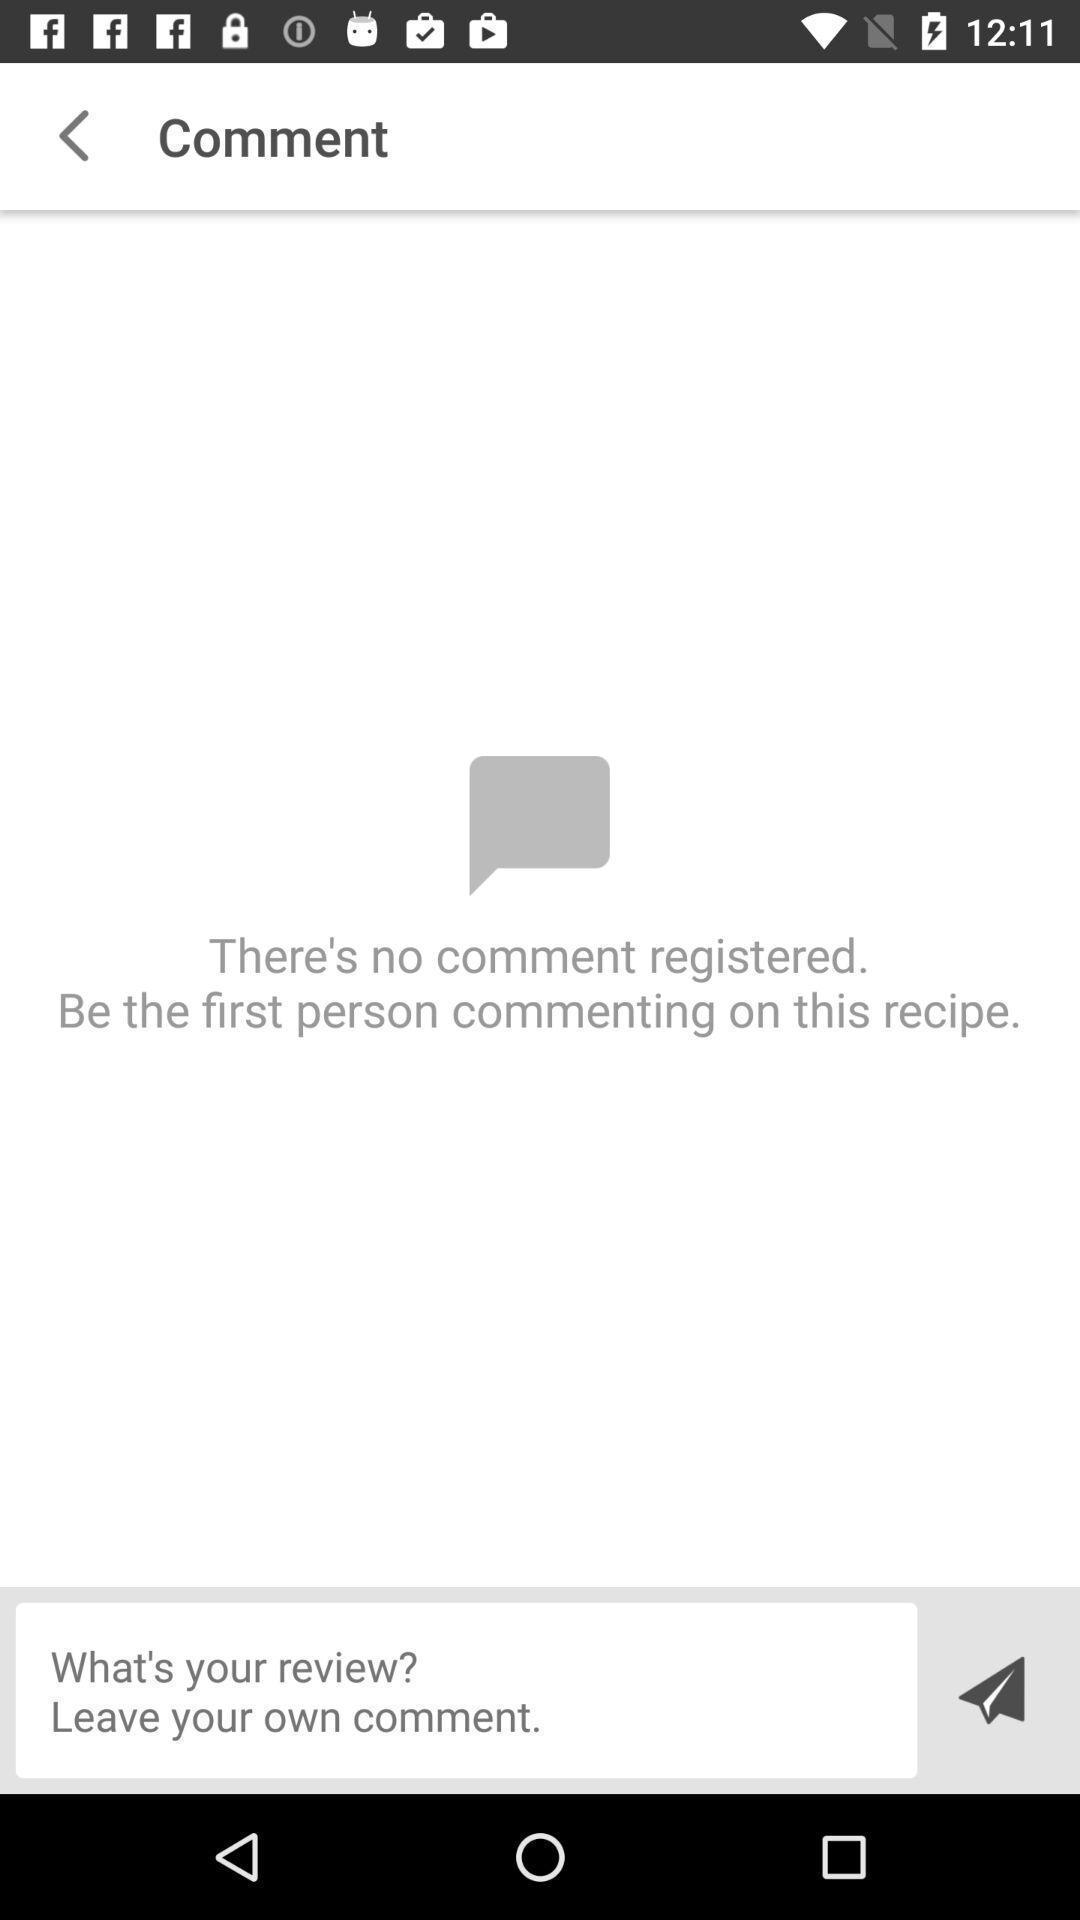Provide a textual representation of this image. Screen displays comment page. 